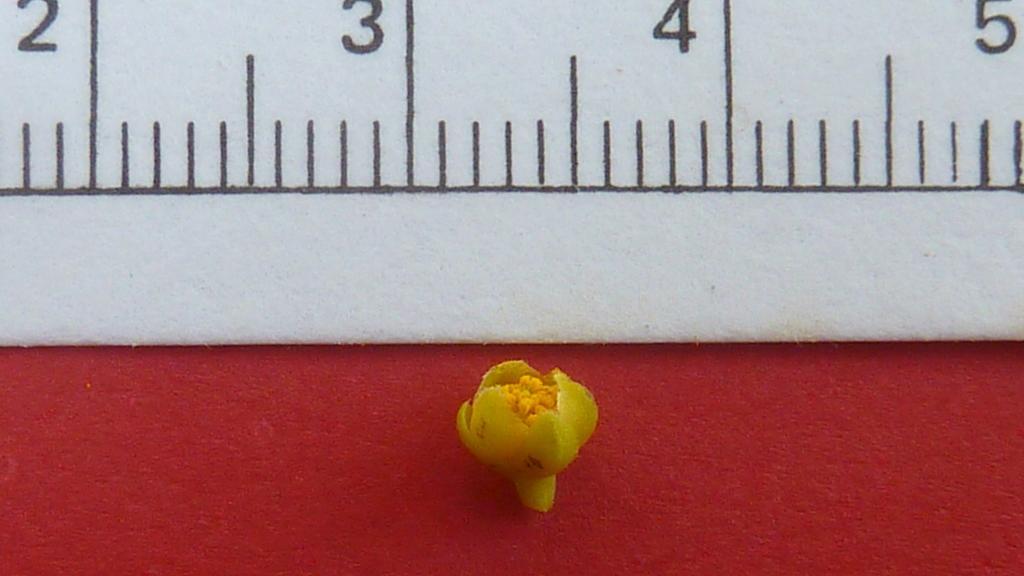Describe this image in one or two sentences. In this image there is an object which is yellow in colour in the center and in the background there is white colour wall and on the wall there are some numbers written on it. 